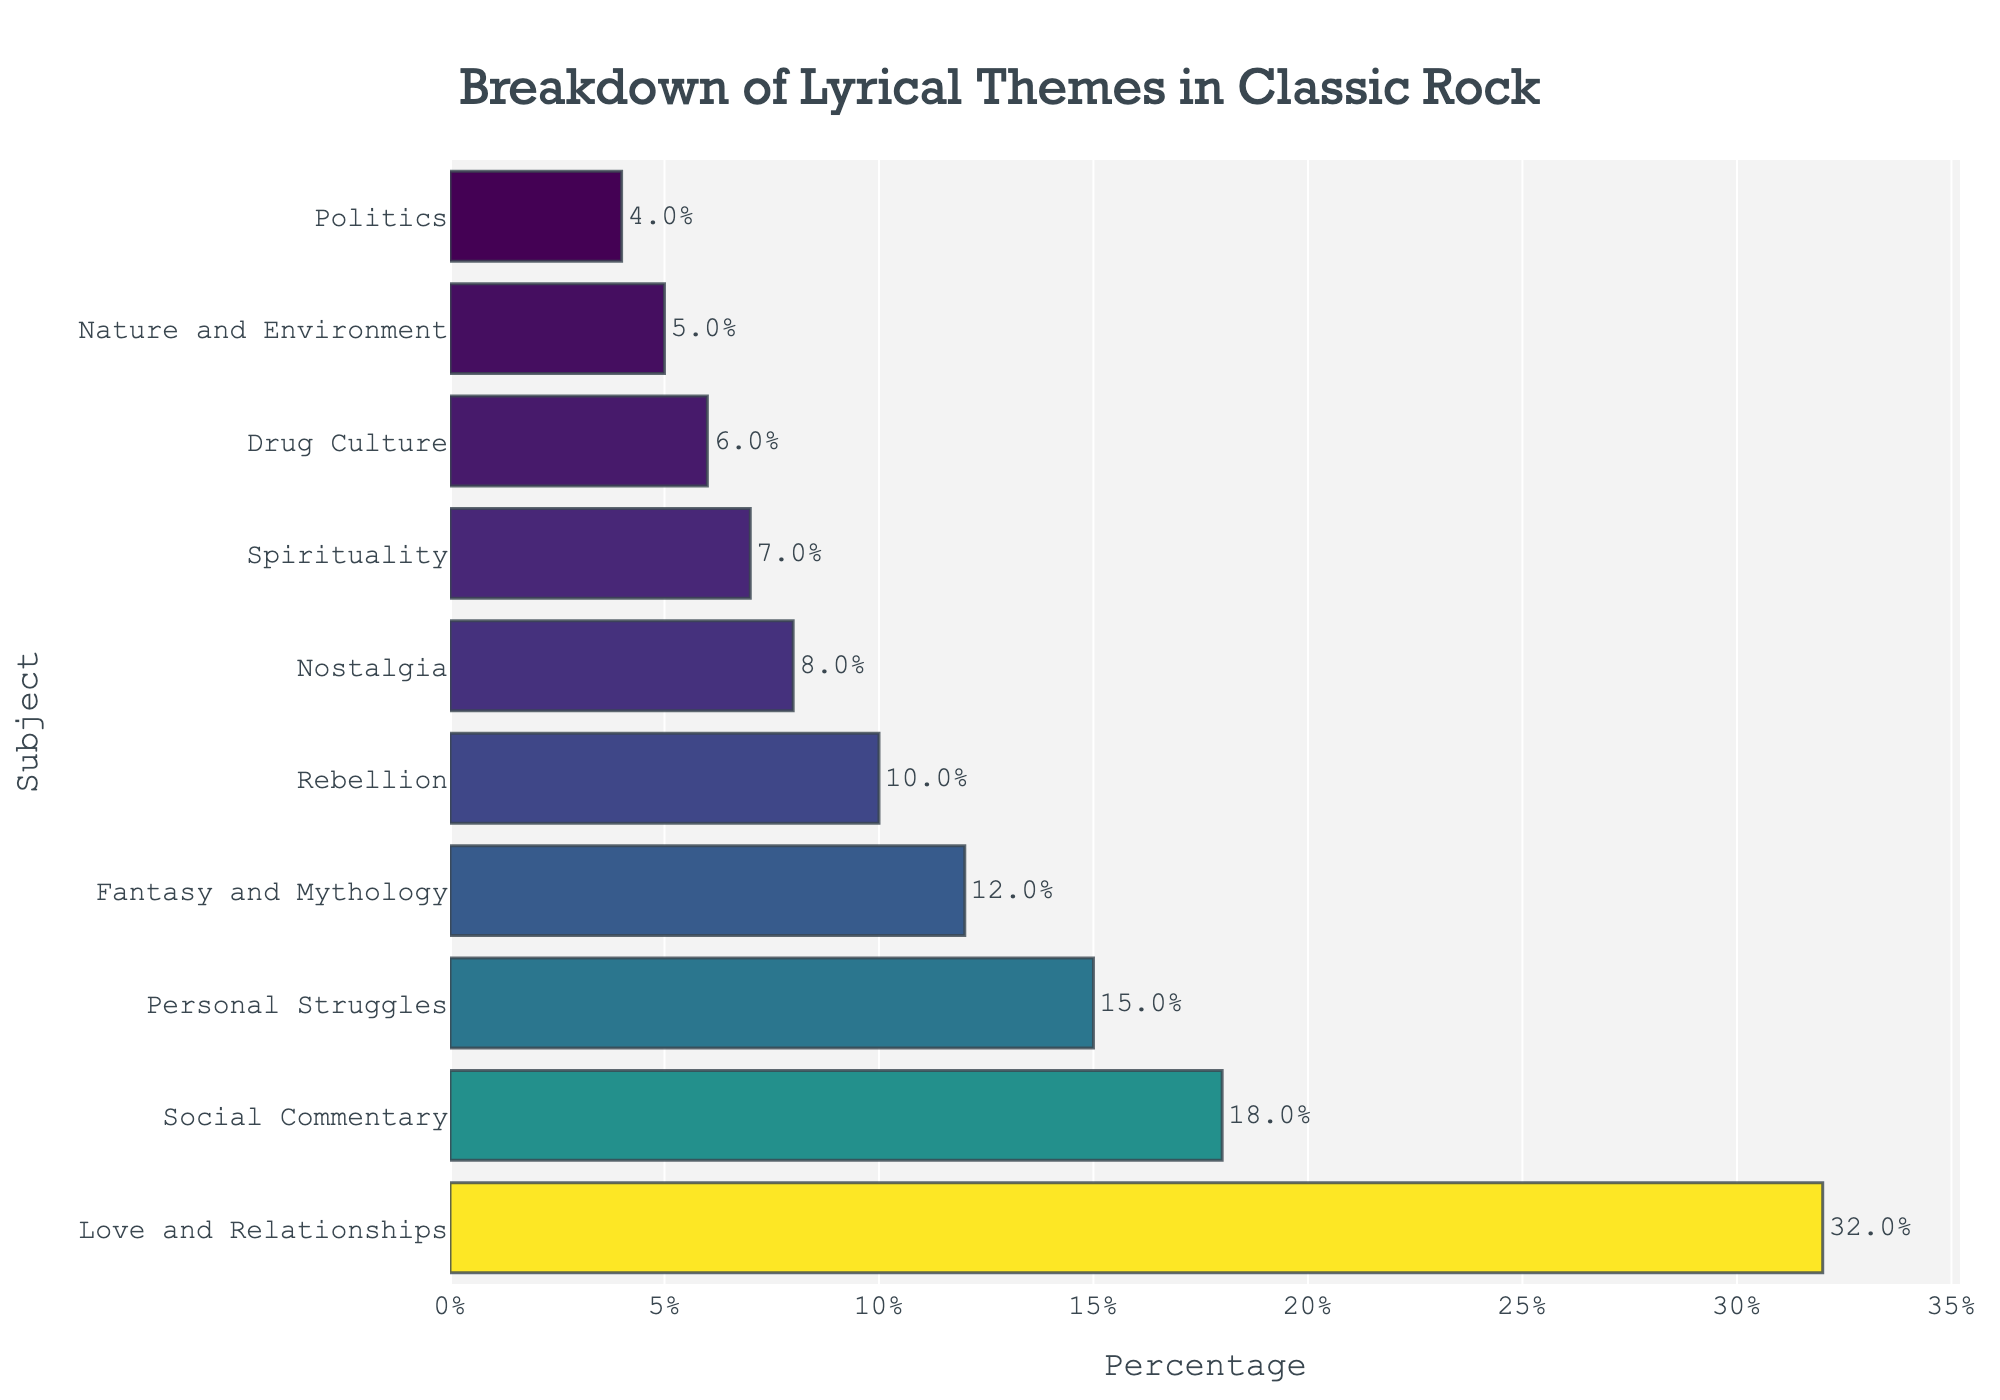What lyrical theme has the highest percentage? The bar chart shows the longest bar for "Love and Relationships," indicating it has the highest percentage.
Answer: Love and Relationships Which lyrical theme has a smaller percentage than "Fantasy and Mythology" but larger than "Politics"? The bar representing "Rebellion" is shorter than "Fantasy and Mythology" but longer than "Politics".
Answer: Rebellion What is the combined percentage of the themes "Personal Struggles" and "Nostalgia"? Add the percentages of "Personal Struggles" (15%) and "Nostalgia" (8%) together. 15% + 8% = 23%.
Answer: 23% How many lyrical themes have a percentage that is greater than 10%? The percentages greater than 10% are for "Love and Relationships" (32%), "Social Commentary" (18%), "Fantasy and Mythology" (12%), and "Personal Struggles" (15%). Count of these themes is 4.
Answer: 4 Which lyrical theme has the lowest percentage, and what is it? The shortest bar on the chart represents "Politics," indicating the lowest percentage.
Answer: Politics, 4% What is the average percentage of "Spirituality" and "Drug Culture"? The percentages of "Spirituality" (7%) and "Drug Culture" (6%) are averaged by adding them together and dividing by 2. (7% + 6%) / 2 = 6.5%.
Answer: 6.5% Is the percentage for "Nature and Environment" higher or lower than " Spirituality"? "Nature and Environment" has a shorter bar compared to "Spirituality," indicating a lower percentage.
Answer: Lower What is the difference in percentage between "Love and Relationships" and "Social Commentary"? Subtract the percentage of "Social Commentary" (18%) from "Love and Relationships" (32%). 32% - 18% = 14%.
Answer: 14% Arrange the themes "Fantasy and Mythology," "Drug Culture," and "Rebellion" in order from highest to lowest percentage. By comparing the bar lengths, the order from highest to lowest is "Fantasy and Mythology" (12%), "Rebellion" (10%), and "Drug Culture" (6%).
Answer: Fantasy and Mythology, Rebellion, Drug Culture Which lyrical themes have an equal or greater percentage than "Social Commentary"? The percentages equal to or greater than "Social Commentary" (18%) are for "Love and Relationships" (32%) and "Social Commentary" itself (18%).
Answer: Love and Relationships, Social Commentary 